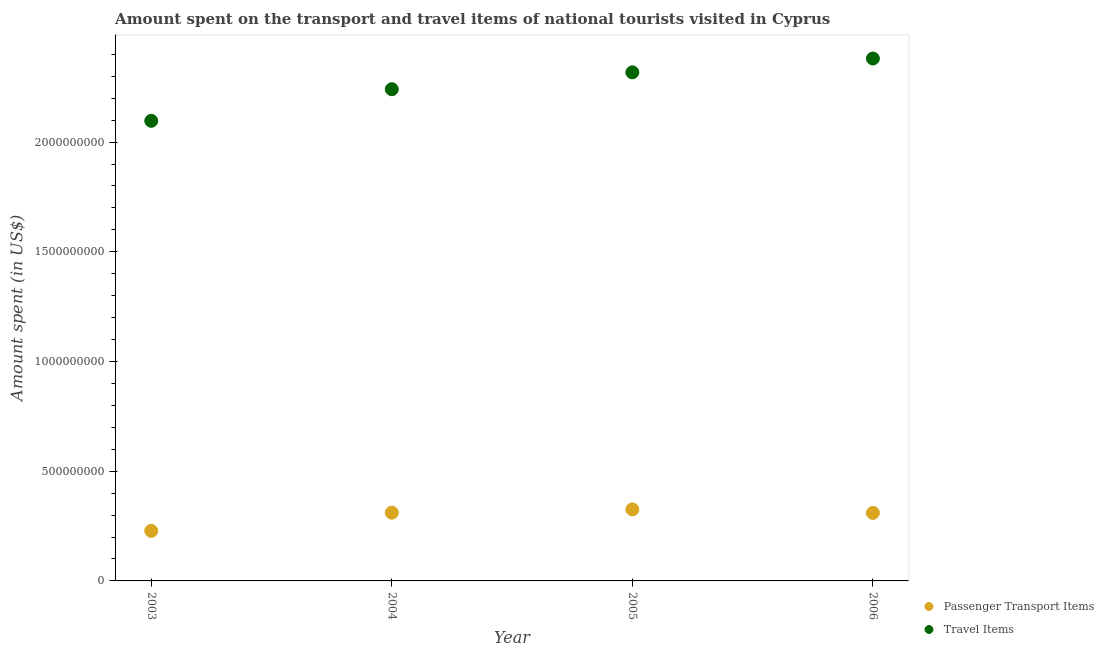What is the amount spent in travel items in 2006?
Offer a terse response. 2.38e+09. Across all years, what is the maximum amount spent on passenger transport items?
Your answer should be very brief. 3.26e+08. Across all years, what is the minimum amount spent on passenger transport items?
Make the answer very short. 2.28e+08. In which year was the amount spent on passenger transport items maximum?
Ensure brevity in your answer.  2005. In which year was the amount spent on passenger transport items minimum?
Ensure brevity in your answer.  2003. What is the total amount spent on passenger transport items in the graph?
Your response must be concise. 1.18e+09. What is the difference between the amount spent in travel items in 2003 and that in 2004?
Give a very brief answer. -1.44e+08. What is the difference between the amount spent on passenger transport items in 2003 and the amount spent in travel items in 2005?
Your answer should be compact. -2.09e+09. What is the average amount spent in travel items per year?
Your answer should be compact. 2.26e+09. In the year 2004, what is the difference between the amount spent in travel items and amount spent on passenger transport items?
Ensure brevity in your answer.  1.93e+09. In how many years, is the amount spent on passenger transport items greater than 1100000000 US$?
Make the answer very short. 0. What is the ratio of the amount spent on passenger transport items in 2004 to that in 2006?
Keep it short and to the point. 1. Is the amount spent in travel items in 2003 less than that in 2006?
Give a very brief answer. Yes. What is the difference between the highest and the second highest amount spent in travel items?
Provide a short and direct response. 6.30e+07. What is the difference between the highest and the lowest amount spent in travel items?
Ensure brevity in your answer.  2.84e+08. Is the sum of the amount spent on passenger transport items in 2004 and 2005 greater than the maximum amount spent in travel items across all years?
Offer a very short reply. No. Is the amount spent on passenger transport items strictly greater than the amount spent in travel items over the years?
Provide a short and direct response. No. How many dotlines are there?
Provide a short and direct response. 2. Are the values on the major ticks of Y-axis written in scientific E-notation?
Give a very brief answer. No. Does the graph contain any zero values?
Your response must be concise. No. Does the graph contain grids?
Offer a very short reply. No. How are the legend labels stacked?
Your response must be concise. Vertical. What is the title of the graph?
Your answer should be very brief. Amount spent on the transport and travel items of national tourists visited in Cyprus. Does "Register a business" appear as one of the legend labels in the graph?
Your answer should be compact. No. What is the label or title of the Y-axis?
Your answer should be very brief. Amount spent (in US$). What is the Amount spent (in US$) of Passenger Transport Items in 2003?
Keep it short and to the point. 2.28e+08. What is the Amount spent (in US$) of Travel Items in 2003?
Your answer should be compact. 2.10e+09. What is the Amount spent (in US$) of Passenger Transport Items in 2004?
Your answer should be very brief. 3.11e+08. What is the Amount spent (in US$) of Travel Items in 2004?
Make the answer very short. 2.24e+09. What is the Amount spent (in US$) of Passenger Transport Items in 2005?
Give a very brief answer. 3.26e+08. What is the Amount spent (in US$) of Travel Items in 2005?
Provide a succinct answer. 2.32e+09. What is the Amount spent (in US$) in Passenger Transport Items in 2006?
Provide a succinct answer. 3.10e+08. What is the Amount spent (in US$) in Travel Items in 2006?
Make the answer very short. 2.38e+09. Across all years, what is the maximum Amount spent (in US$) in Passenger Transport Items?
Provide a short and direct response. 3.26e+08. Across all years, what is the maximum Amount spent (in US$) in Travel Items?
Offer a terse response. 2.38e+09. Across all years, what is the minimum Amount spent (in US$) in Passenger Transport Items?
Give a very brief answer. 2.28e+08. Across all years, what is the minimum Amount spent (in US$) of Travel Items?
Provide a short and direct response. 2.10e+09. What is the total Amount spent (in US$) in Passenger Transport Items in the graph?
Ensure brevity in your answer.  1.18e+09. What is the total Amount spent (in US$) of Travel Items in the graph?
Provide a short and direct response. 9.04e+09. What is the difference between the Amount spent (in US$) in Passenger Transport Items in 2003 and that in 2004?
Offer a terse response. -8.30e+07. What is the difference between the Amount spent (in US$) of Travel Items in 2003 and that in 2004?
Offer a terse response. -1.44e+08. What is the difference between the Amount spent (in US$) in Passenger Transport Items in 2003 and that in 2005?
Offer a terse response. -9.80e+07. What is the difference between the Amount spent (in US$) in Travel Items in 2003 and that in 2005?
Offer a very short reply. -2.21e+08. What is the difference between the Amount spent (in US$) in Passenger Transport Items in 2003 and that in 2006?
Provide a short and direct response. -8.20e+07. What is the difference between the Amount spent (in US$) of Travel Items in 2003 and that in 2006?
Your answer should be very brief. -2.84e+08. What is the difference between the Amount spent (in US$) of Passenger Transport Items in 2004 and that in 2005?
Ensure brevity in your answer.  -1.50e+07. What is the difference between the Amount spent (in US$) of Travel Items in 2004 and that in 2005?
Give a very brief answer. -7.70e+07. What is the difference between the Amount spent (in US$) in Travel Items in 2004 and that in 2006?
Offer a very short reply. -1.40e+08. What is the difference between the Amount spent (in US$) of Passenger Transport Items in 2005 and that in 2006?
Ensure brevity in your answer.  1.60e+07. What is the difference between the Amount spent (in US$) of Travel Items in 2005 and that in 2006?
Provide a succinct answer. -6.30e+07. What is the difference between the Amount spent (in US$) of Passenger Transport Items in 2003 and the Amount spent (in US$) of Travel Items in 2004?
Make the answer very short. -2.01e+09. What is the difference between the Amount spent (in US$) in Passenger Transport Items in 2003 and the Amount spent (in US$) in Travel Items in 2005?
Your answer should be very brief. -2.09e+09. What is the difference between the Amount spent (in US$) of Passenger Transport Items in 2003 and the Amount spent (in US$) of Travel Items in 2006?
Ensure brevity in your answer.  -2.15e+09. What is the difference between the Amount spent (in US$) of Passenger Transport Items in 2004 and the Amount spent (in US$) of Travel Items in 2005?
Provide a short and direct response. -2.01e+09. What is the difference between the Amount spent (in US$) of Passenger Transport Items in 2004 and the Amount spent (in US$) of Travel Items in 2006?
Provide a succinct answer. -2.07e+09. What is the difference between the Amount spent (in US$) of Passenger Transport Items in 2005 and the Amount spent (in US$) of Travel Items in 2006?
Offer a very short reply. -2.06e+09. What is the average Amount spent (in US$) in Passenger Transport Items per year?
Provide a succinct answer. 2.94e+08. What is the average Amount spent (in US$) of Travel Items per year?
Keep it short and to the point. 2.26e+09. In the year 2003, what is the difference between the Amount spent (in US$) in Passenger Transport Items and Amount spent (in US$) in Travel Items?
Provide a short and direct response. -1.87e+09. In the year 2004, what is the difference between the Amount spent (in US$) of Passenger Transport Items and Amount spent (in US$) of Travel Items?
Your response must be concise. -1.93e+09. In the year 2005, what is the difference between the Amount spent (in US$) of Passenger Transport Items and Amount spent (in US$) of Travel Items?
Your answer should be very brief. -1.99e+09. In the year 2006, what is the difference between the Amount spent (in US$) of Passenger Transport Items and Amount spent (in US$) of Travel Items?
Give a very brief answer. -2.07e+09. What is the ratio of the Amount spent (in US$) of Passenger Transport Items in 2003 to that in 2004?
Ensure brevity in your answer.  0.73. What is the ratio of the Amount spent (in US$) in Travel Items in 2003 to that in 2004?
Provide a succinct answer. 0.94. What is the ratio of the Amount spent (in US$) of Passenger Transport Items in 2003 to that in 2005?
Make the answer very short. 0.7. What is the ratio of the Amount spent (in US$) in Travel Items in 2003 to that in 2005?
Provide a succinct answer. 0.9. What is the ratio of the Amount spent (in US$) in Passenger Transport Items in 2003 to that in 2006?
Your answer should be very brief. 0.74. What is the ratio of the Amount spent (in US$) in Travel Items in 2003 to that in 2006?
Provide a short and direct response. 0.88. What is the ratio of the Amount spent (in US$) in Passenger Transport Items in 2004 to that in 2005?
Give a very brief answer. 0.95. What is the ratio of the Amount spent (in US$) in Travel Items in 2004 to that in 2005?
Keep it short and to the point. 0.97. What is the ratio of the Amount spent (in US$) of Passenger Transport Items in 2004 to that in 2006?
Provide a short and direct response. 1. What is the ratio of the Amount spent (in US$) in Travel Items in 2004 to that in 2006?
Provide a short and direct response. 0.94. What is the ratio of the Amount spent (in US$) in Passenger Transport Items in 2005 to that in 2006?
Your answer should be compact. 1.05. What is the ratio of the Amount spent (in US$) of Travel Items in 2005 to that in 2006?
Provide a short and direct response. 0.97. What is the difference between the highest and the second highest Amount spent (in US$) in Passenger Transport Items?
Offer a very short reply. 1.50e+07. What is the difference between the highest and the second highest Amount spent (in US$) of Travel Items?
Your answer should be very brief. 6.30e+07. What is the difference between the highest and the lowest Amount spent (in US$) in Passenger Transport Items?
Your response must be concise. 9.80e+07. What is the difference between the highest and the lowest Amount spent (in US$) of Travel Items?
Your response must be concise. 2.84e+08. 